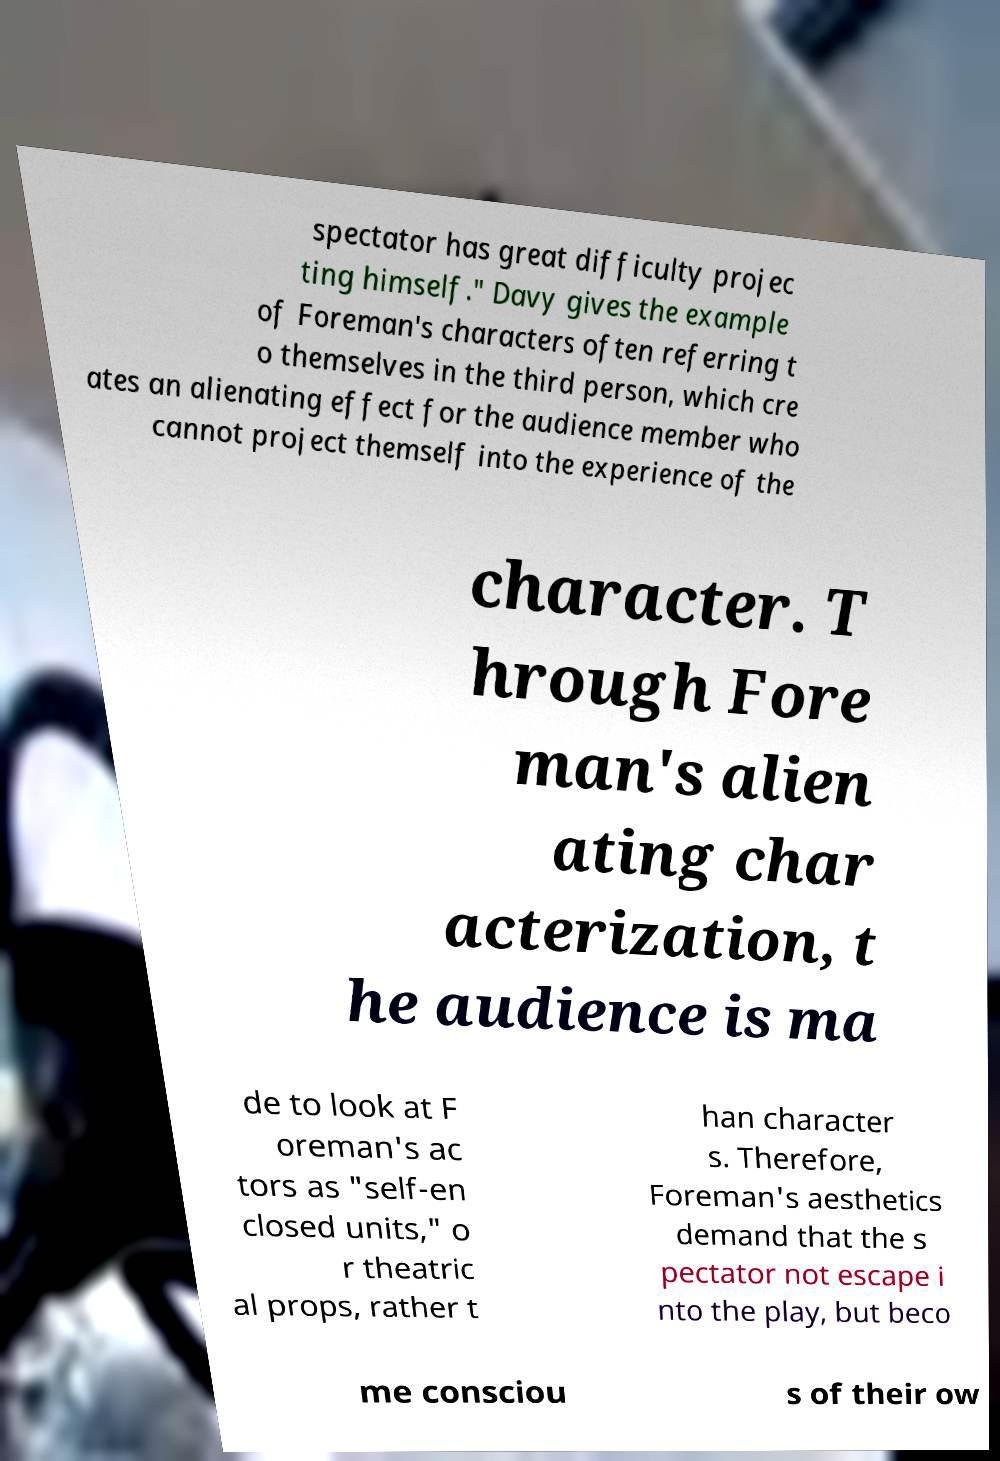Can you read and provide the text displayed in the image?This photo seems to have some interesting text. Can you extract and type it out for me? spectator has great difficulty projec ting himself." Davy gives the example of Foreman's characters often referring t o themselves in the third person, which cre ates an alienating effect for the audience member who cannot project themself into the experience of the character. T hrough Fore man's alien ating char acterization, t he audience is ma de to look at F oreman's ac tors as "self-en closed units," o r theatric al props, rather t han character s. Therefore, Foreman's aesthetics demand that the s pectator not escape i nto the play, but beco me consciou s of their ow 